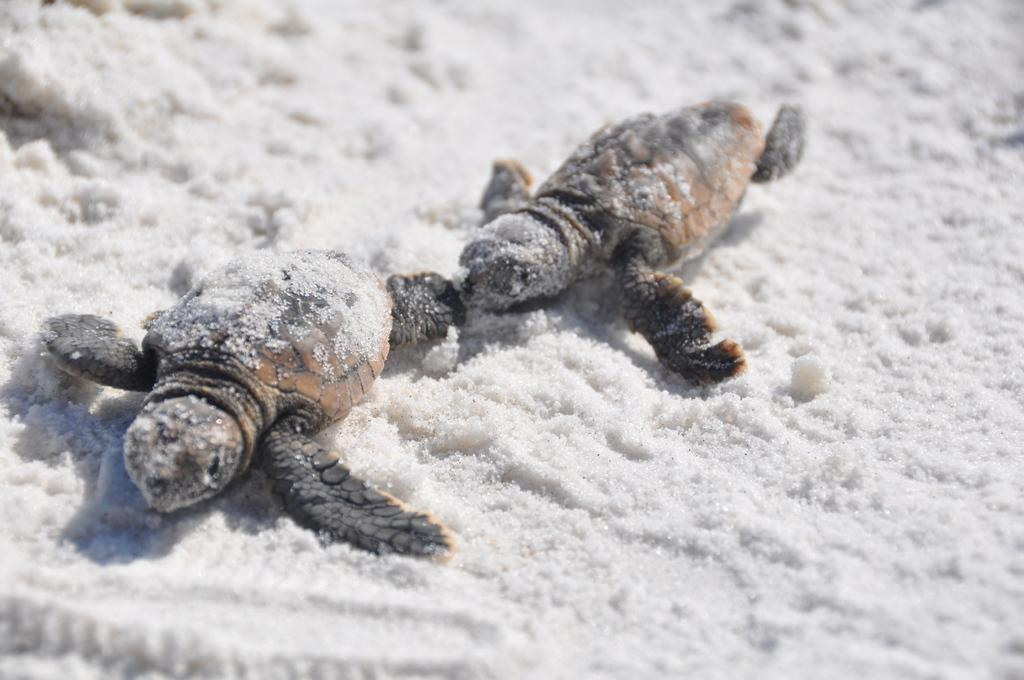How many baby tortoises are present in the image? There are 2 baby tortoises in the image. What is the condition of the ground in the image? The ground is salty. What type of headwear is visible on the baby tortoises in the image? There is no headwear visible on the baby tortoises in the image. What historical event is depicted in the image? The image does not depict any historical event; it features baby tortoises on salty ground. What type of scale is used to measure the size of the baby tortoises in the image? There is no scale present in the image to measure the size of the baby tortoises. 